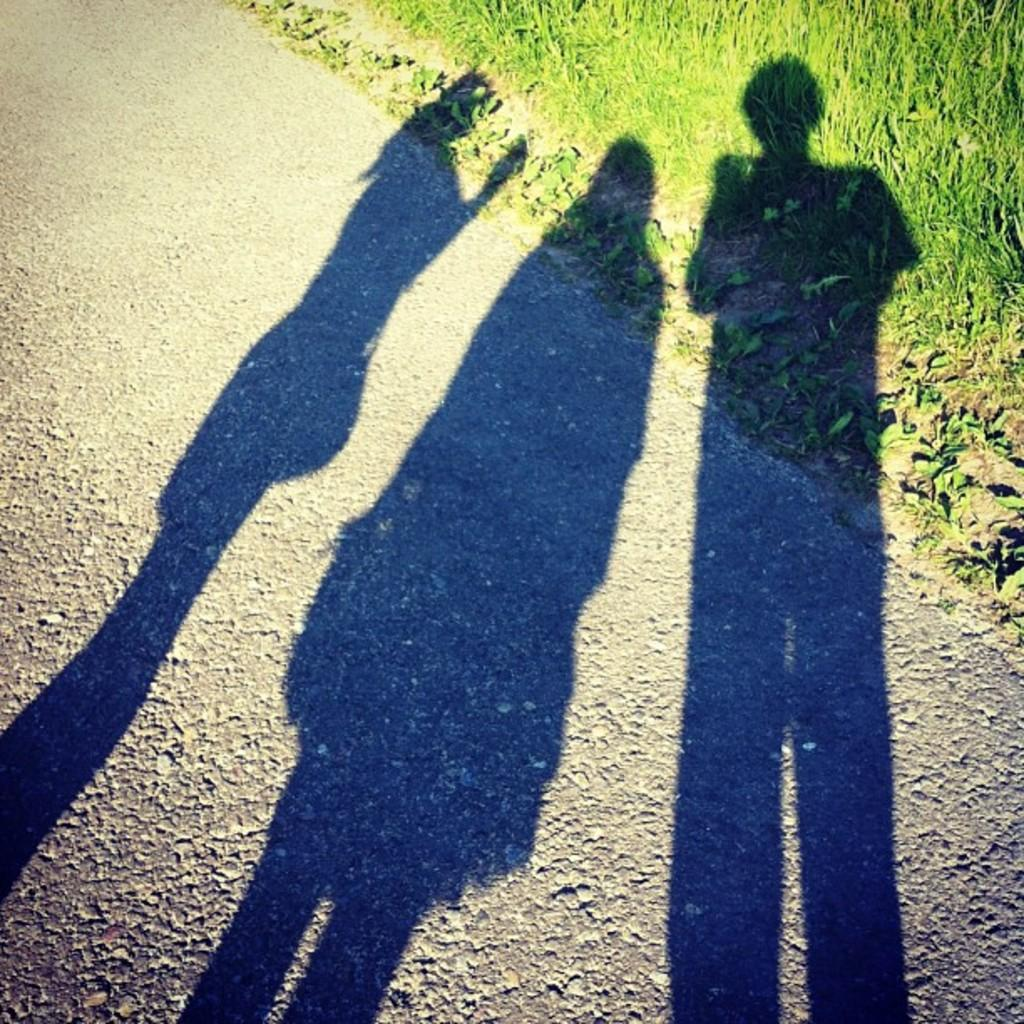What can be seen in the image that represents the presence of three persons? There is a shadow of three persons in the image. What type of pathway is visible in the image? There is a road visible in the image. What type of vegetation is present in the image? There is grass in the image. Can you tell me how many geese are walking along the road in the image? There are no geese present in the image; it only shows a shadow of three persons, a road, and grass. Is there any visible dust in the image? There is no mention of dust in the provided facts, and it cannot be determined from the image. 